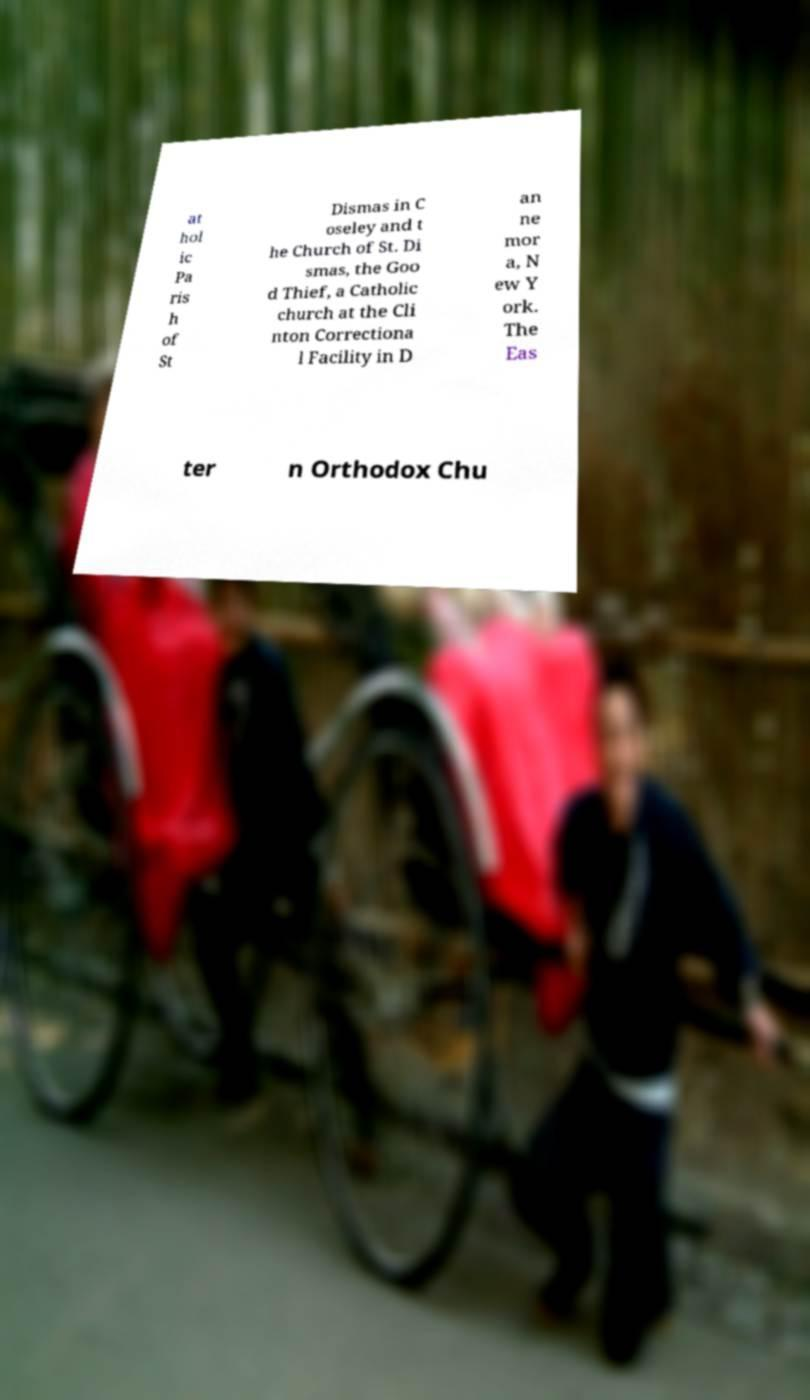I need the written content from this picture converted into text. Can you do that? at hol ic Pa ris h of St Dismas in C oseley and t he Church of St. Di smas, the Goo d Thief, a Catholic church at the Cli nton Correctiona l Facility in D an ne mor a, N ew Y ork. The Eas ter n Orthodox Chu 